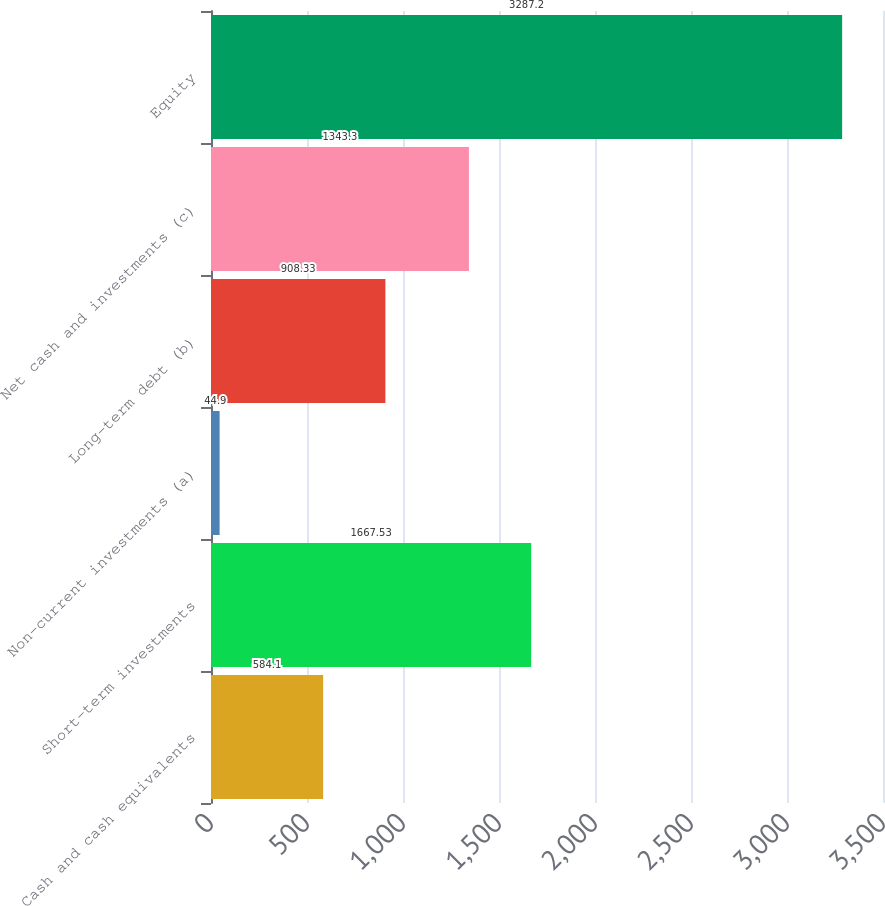Convert chart to OTSL. <chart><loc_0><loc_0><loc_500><loc_500><bar_chart><fcel>Cash and cash equivalents<fcel>Short-term investments<fcel>Non-current investments (a)<fcel>Long-term debt (b)<fcel>Net cash and investments (c)<fcel>Equity<nl><fcel>584.1<fcel>1667.53<fcel>44.9<fcel>908.33<fcel>1343.3<fcel>3287.2<nl></chart> 